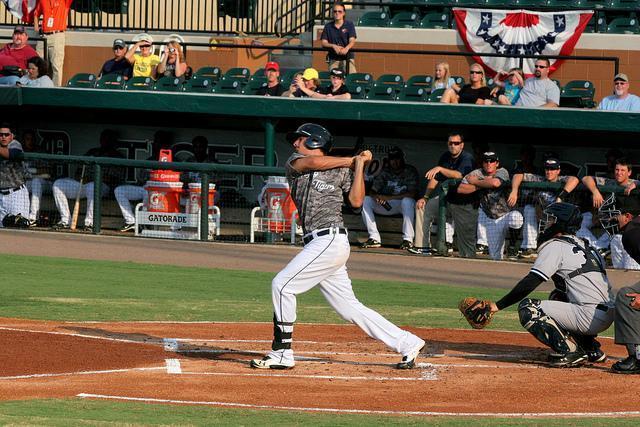How many people are in the photo?
Give a very brief answer. 10. How many dogs are playing in the ocean?
Give a very brief answer. 0. 